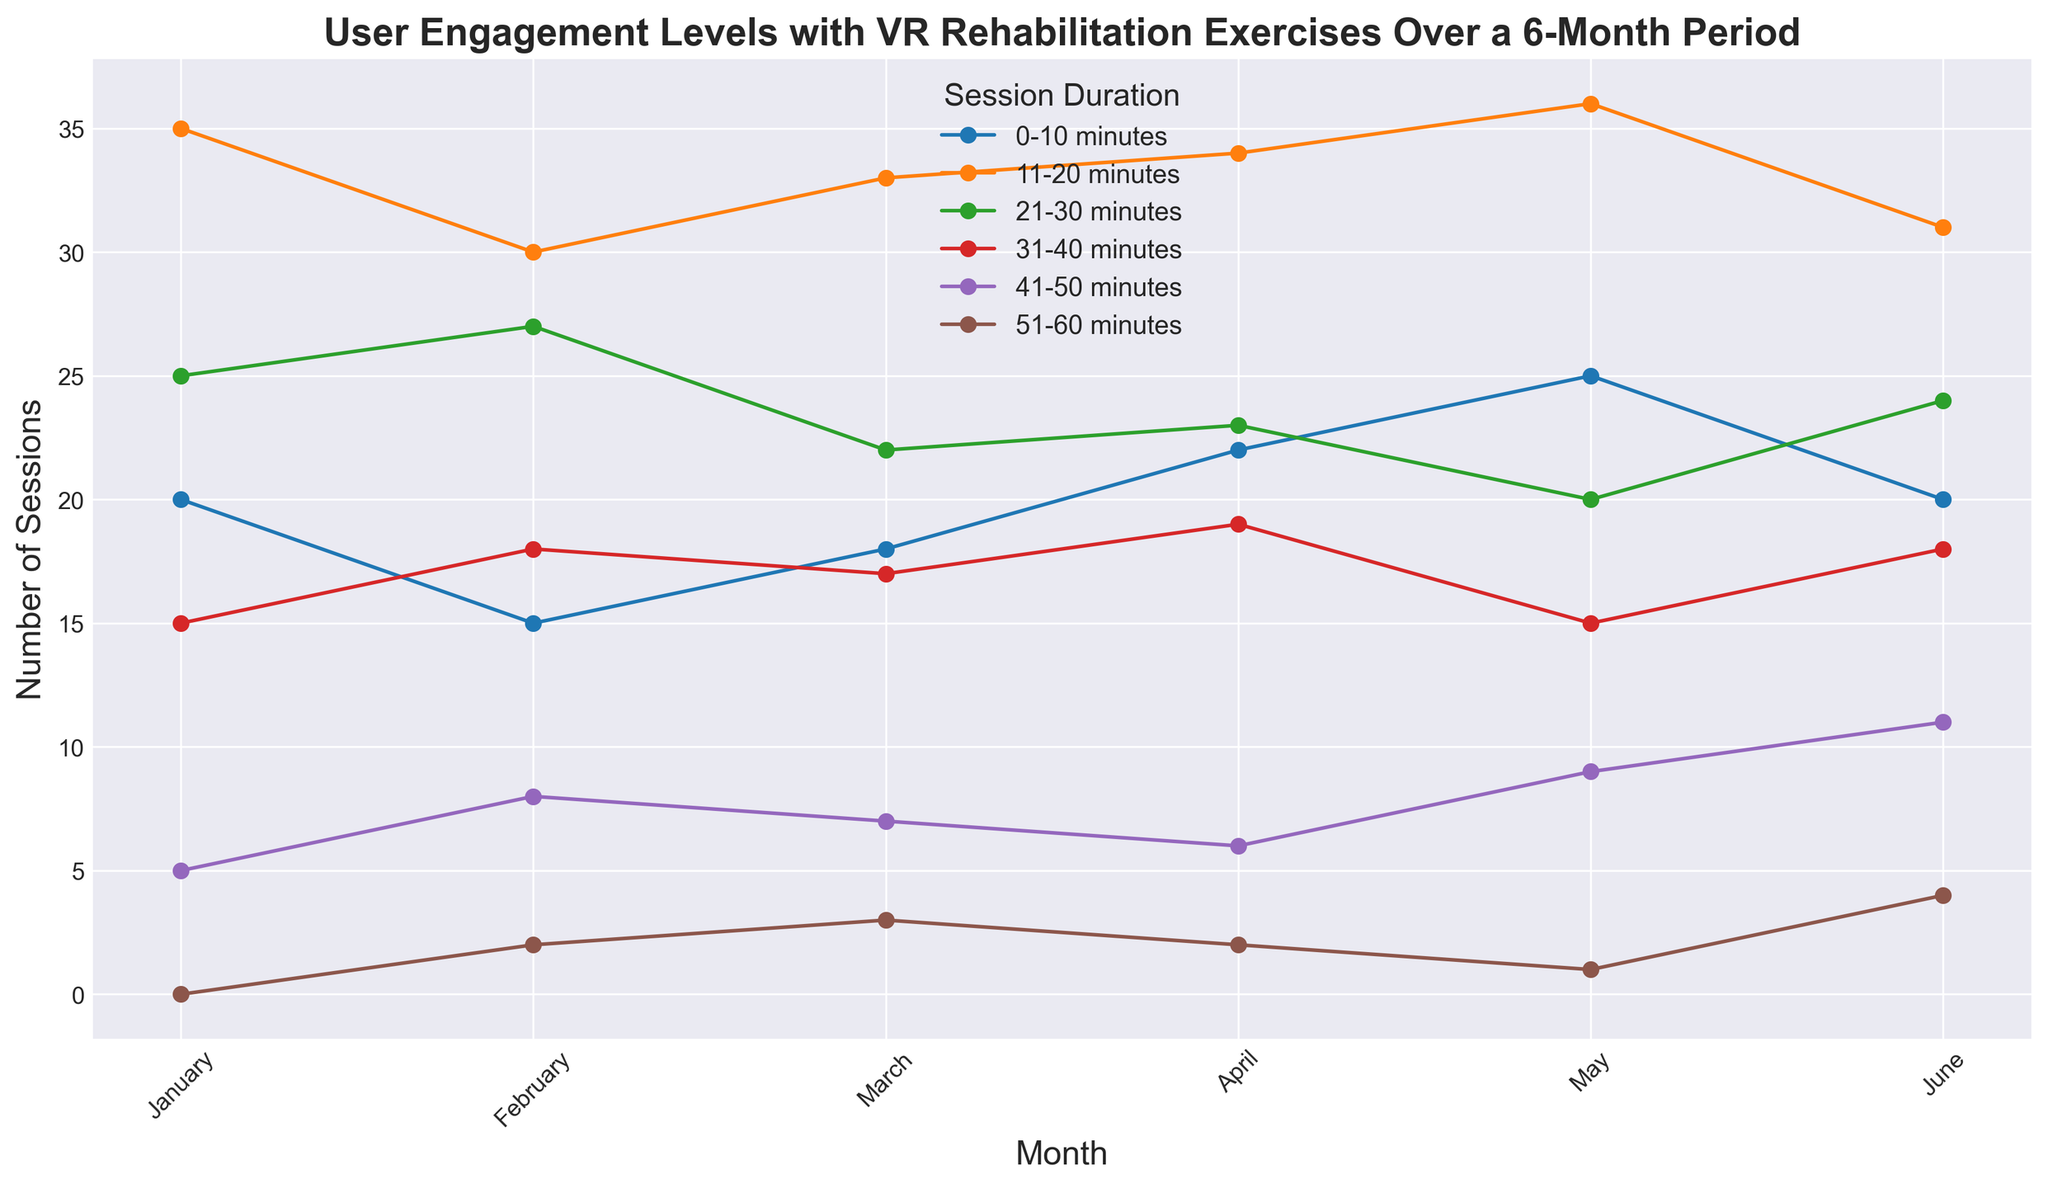Which month had the highest number of sessions lasting 11-20 minutes? Look for the line labeled '11-20 minutes' and identify the highest peak, which is in May.
Answer: May What is the difference in the number of sessions between January and June for sessions lasting 0-10 minutes? Identify the points for January and June on the '0-10 minutes' line, which are 20 and 20, respectively, and calculate the difference: 20 - 20 = 0.
Answer: 0 Which session duration saw the most consistent engagement levels over the 6-month period? The '11-20 minutes' line shows smaller fluctuations compared to other durations, indicating consistent engagement levels.
Answer: 11-20 minutes Between which two consecutive months did the number of sessions lasting 31-40 minutes change the most? Look for the largest vertical distance between consecutive points on the '31-40 minutes' line, which is between January (15) and February (18). The change is 18 - 15 = 3.
Answer: January and February What is the average number of sessions lasting 41-50 minutes over the 6-month period? Sum the number of sessions for '41-50 minutes' over all months: 5 + 8 + 7 + 6 + 9 + 11 = 46. Divide by 6 months: 46/6 ≈ 7.67.
Answer: 7.67 Do more users tend to participate in sessions lasting 0-10 minutes or 21-30 minutes in March? Compare the points for March on the '0-10 minutes' and '21-30 minutes' lines, which are 18 and 22, respectively. More users participate in the latter.
Answer: 21-30 minutes Which month shows the highest engagement in long-duration sessions (51-60 minutes)? Identify the highest point on the '51-60 minutes' line, which is in June with 4 sessions.
Answer: June What is the median number of sessions for 31-40 minutes over the 6 months? List the sessions for '31-40 minutes' in order: [15, 17, 18, 18, 19, 15]. The median is the average of the two middle values (18 and 18): (18 + 18)/2 = 18.
Answer: 18 How did the user engagement for 0-10 minutes sessions change from January to June? Check the '0-10 minutes' line at January (20) and June (20) to observe that it remained the same.
Answer: No change What is the total number of sessions lasting 21-30 minutes over the entire 6-month period? Sum the counts for '21-30 minutes' over all months: 25 + 27 + 22 + 23 + 20 + 24 = 141.
Answer: 141 